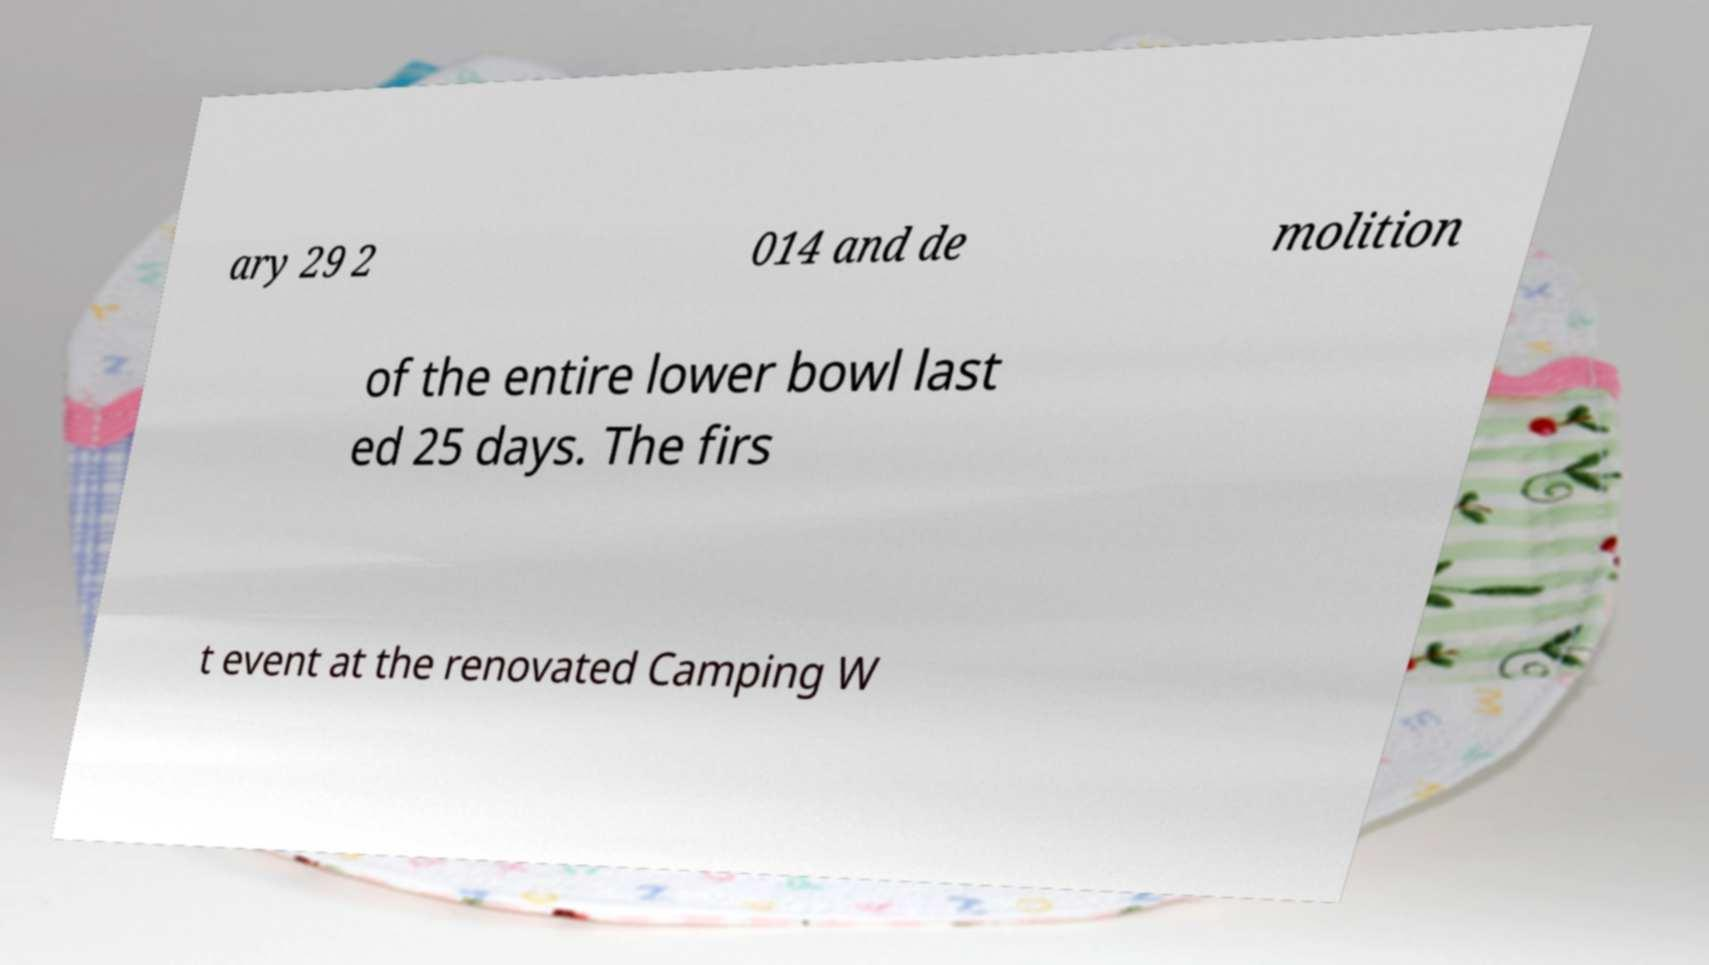What messages or text are displayed in this image? I need them in a readable, typed format. ary 29 2 014 and de molition of the entire lower bowl last ed 25 days. The firs t event at the renovated Camping W 